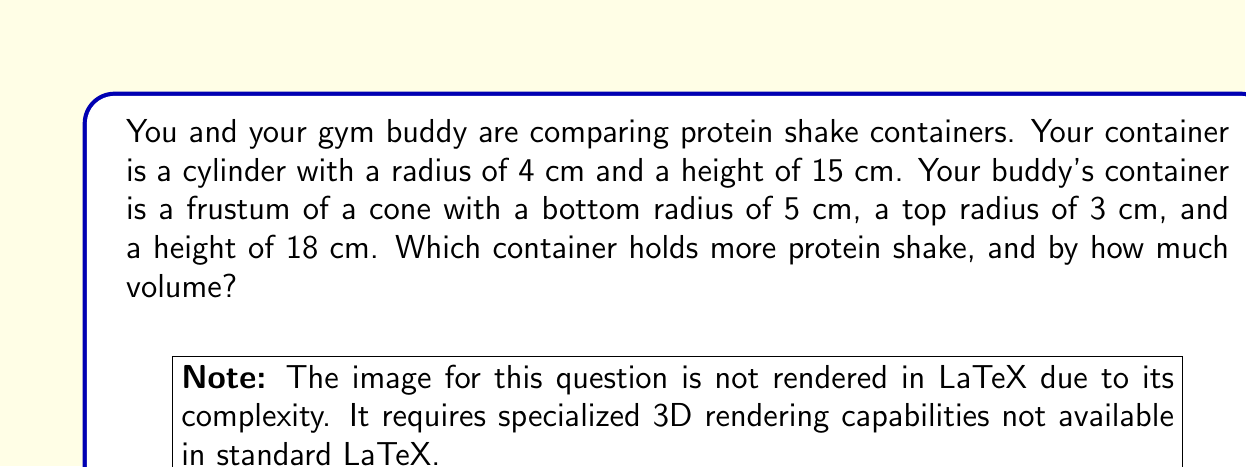What is the answer to this math problem? Let's approach this step-by-step:

1) For your cylindrical container:
   The volume of a cylinder is given by $V = \pi r^2 h$
   Where $r$ is the radius and $h$ is the height.
   
   $V_{cylinder} = \pi \cdot 4^2 \cdot 15 = 240\pi$ cm³

2) For your buddy's frustum container:
   The volume of a frustum of a cone is given by:
   $V = \frac{1}{3}\pi h(R^2 + r^2 + Rr)$
   Where $h$ is the height, $R$ is the radius of the base, and $r$ is the radius of the top.

   $V_{frustum} = \frac{1}{3}\pi \cdot 18(5^2 + 3^2 + 5 \cdot 3)$
                $= 6\pi(25 + 9 + 15)$
                $= 6\pi \cdot 49$
                $= 294\pi$ cm³

3) To find the difference:
   $294\pi - 240\pi = 54\pi$ cm³

Therefore, your buddy's frustum-shaped container holds more protein shake.
Answer: Your buddy's frustum-shaped container holds $54\pi \approx 169.65$ cm³ more protein shake than your cylindrical container. 